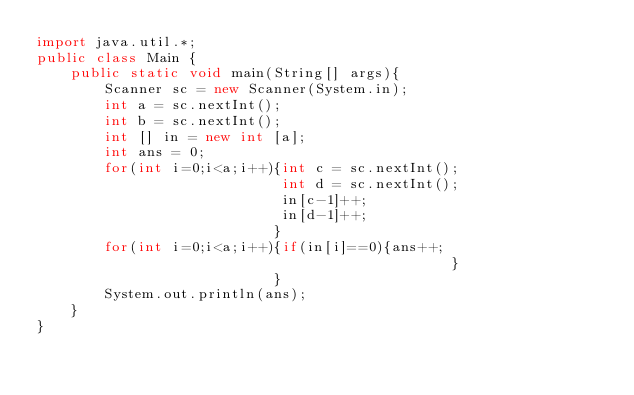<code> <loc_0><loc_0><loc_500><loc_500><_Java_>import java.util.*;
public class Main {
	public static void main(String[] args){
		Scanner sc = new Scanner(System.in);
		int a = sc.nextInt();
        int b = sc.nextInt();
		int [] in = new int [a]; 
        int ans = 0;
        for(int i=0;i<a;i++){int c = sc.nextInt();
                             int d = sc.nextInt();
                             in[c-1]++;
                             in[d-1]++;
                            }		
        for(int i=0;i<a;i++){if(in[i]==0){ans++;
                                                 }
                            }     
		System.out.println(ans);
	}
}</code> 